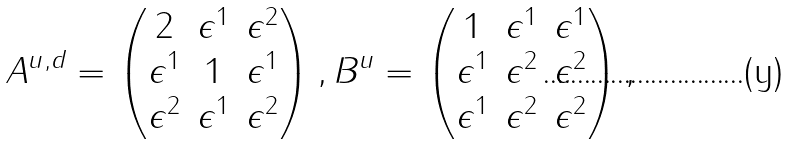<formula> <loc_0><loc_0><loc_500><loc_500>A ^ { u , d } = \left ( \begin{matrix} 2 & \epsilon ^ { 1 } & \epsilon ^ { 2 } \\ \epsilon ^ { 1 } & 1 & \epsilon ^ { 1 } \\ \epsilon ^ { 2 } & \epsilon ^ { 1 } & \epsilon ^ { 2 } \\ \end{matrix} \right ) , B ^ { u } = \left ( \begin{matrix} 1 & \epsilon ^ { 1 } & \epsilon ^ { 1 } \\ \epsilon ^ { 1 } & \epsilon ^ { 2 } & \epsilon ^ { 2 } \\ \epsilon ^ { 1 } & \epsilon ^ { 2 } & \epsilon ^ { 2 } \\ \end{matrix} \right ) ,</formula> 